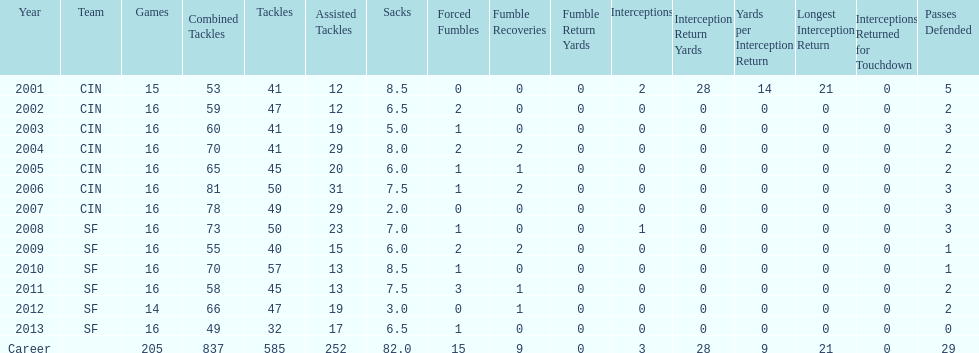What is the career average for tackles made by this player? 45. 